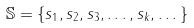Convert formula to latex. <formula><loc_0><loc_0><loc_500><loc_500>\mathbb { S } = \{ s _ { 1 } , s _ { 2 } , s _ { 3 } , \dots , s _ { k } , \dots \}</formula> 